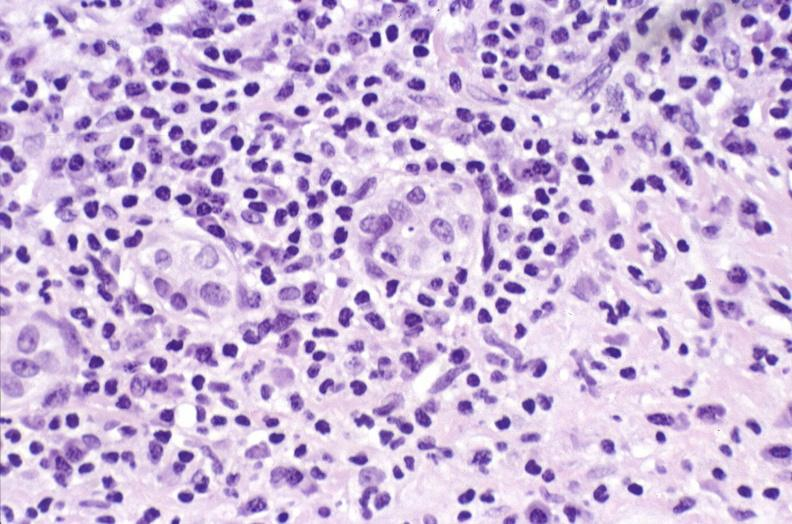s liver present?
Answer the question using a single word or phrase. Yes 